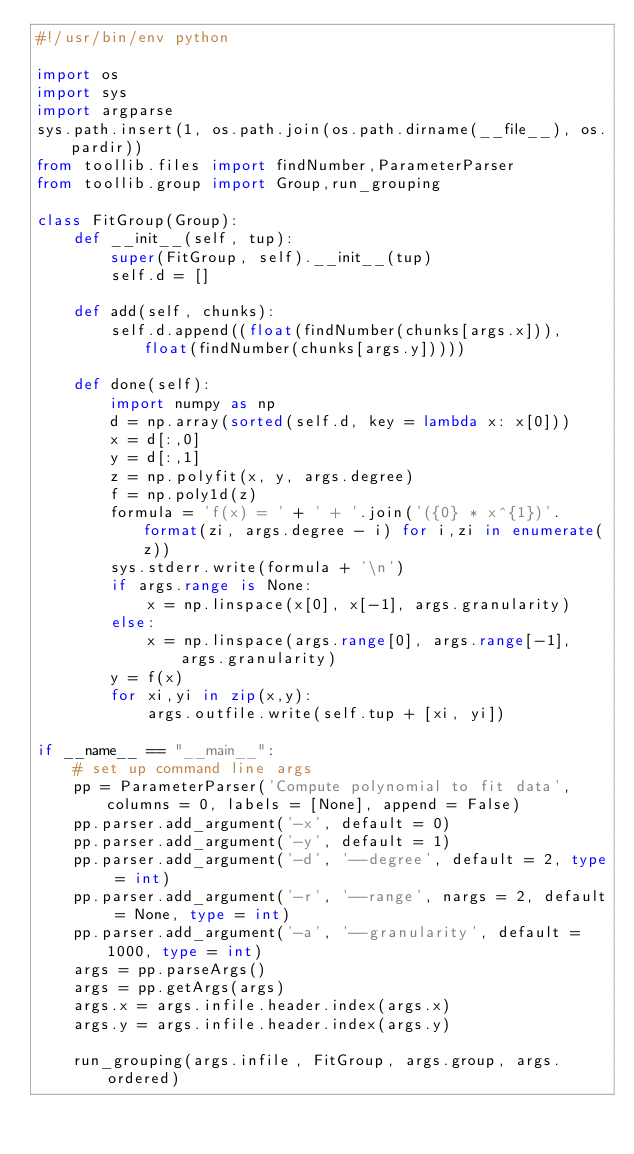Convert code to text. <code><loc_0><loc_0><loc_500><loc_500><_Python_>#!/usr/bin/env python

import os
import sys
import argparse
sys.path.insert(1, os.path.join(os.path.dirname(__file__), os.pardir))
from toollib.files import findNumber,ParameterParser
from toollib.group import Group,run_grouping

class FitGroup(Group):
    def __init__(self, tup):
        super(FitGroup, self).__init__(tup)
        self.d = []

    def add(self, chunks):
        self.d.append((float(findNumber(chunks[args.x])), float(findNumber(chunks[args.y]))))

    def done(self):
        import numpy as np
        d = np.array(sorted(self.d, key = lambda x: x[0]))
        x = d[:,0]
        y = d[:,1]
        z = np.polyfit(x, y, args.degree)
        f = np.poly1d(z)
        formula = 'f(x) = ' + ' + '.join('({0} * x^{1})'.format(zi, args.degree - i) for i,zi in enumerate(z))
        sys.stderr.write(formula + '\n')
        if args.range is None:
            x = np.linspace(x[0], x[-1], args.granularity)
        else:
            x = np.linspace(args.range[0], args.range[-1], args.granularity)
        y = f(x)
        for xi,yi in zip(x,y):
            args.outfile.write(self.tup + [xi, yi])

if __name__ == "__main__":
    # set up command line args
    pp = ParameterParser('Compute polynomial to fit data', columns = 0, labels = [None], append = False)
    pp.parser.add_argument('-x', default = 0)
    pp.parser.add_argument('-y', default = 1)
    pp.parser.add_argument('-d', '--degree', default = 2, type = int)
    pp.parser.add_argument('-r', '--range', nargs = 2, default = None, type = int)
    pp.parser.add_argument('-a', '--granularity', default = 1000, type = int)
    args = pp.parseArgs()
    args = pp.getArgs(args)
    args.x = args.infile.header.index(args.x)
    args.y = args.infile.header.index(args.y)

    run_grouping(args.infile, FitGroup, args.group, args.ordered)
</code> 